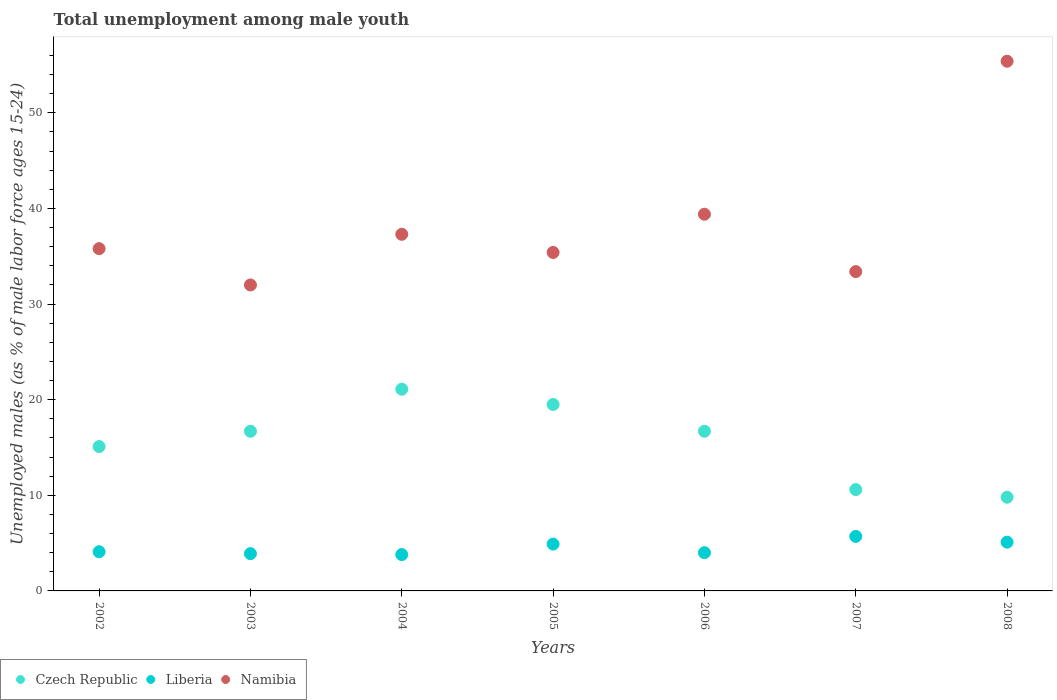How many different coloured dotlines are there?
Offer a very short reply. 3. What is the percentage of unemployed males in in Czech Republic in 2002?
Offer a terse response. 15.1. Across all years, what is the maximum percentage of unemployed males in in Liberia?
Offer a very short reply. 5.7. Across all years, what is the minimum percentage of unemployed males in in Liberia?
Make the answer very short. 3.8. In which year was the percentage of unemployed males in in Namibia maximum?
Provide a succinct answer. 2008. In which year was the percentage of unemployed males in in Namibia minimum?
Your response must be concise. 2003. What is the total percentage of unemployed males in in Liberia in the graph?
Offer a very short reply. 31.5. What is the difference between the percentage of unemployed males in in Czech Republic in 2002 and that in 2006?
Provide a short and direct response. -1.6. What is the difference between the percentage of unemployed males in in Namibia in 2004 and the percentage of unemployed males in in Czech Republic in 2007?
Your answer should be compact. 26.7. What is the average percentage of unemployed males in in Namibia per year?
Your response must be concise. 38.39. In the year 2005, what is the difference between the percentage of unemployed males in in Namibia and percentage of unemployed males in in Czech Republic?
Offer a very short reply. 15.9. What is the ratio of the percentage of unemployed males in in Namibia in 2005 to that in 2006?
Provide a succinct answer. 0.9. What is the difference between the highest and the second highest percentage of unemployed males in in Liberia?
Offer a very short reply. 0.6. What is the difference between the highest and the lowest percentage of unemployed males in in Namibia?
Offer a very short reply. 23.4. In how many years, is the percentage of unemployed males in in Liberia greater than the average percentage of unemployed males in in Liberia taken over all years?
Your answer should be very brief. 3. Is it the case that in every year, the sum of the percentage of unemployed males in in Namibia and percentage of unemployed males in in Czech Republic  is greater than the percentage of unemployed males in in Liberia?
Offer a terse response. Yes. How many years are there in the graph?
Provide a short and direct response. 7. Are the values on the major ticks of Y-axis written in scientific E-notation?
Offer a terse response. No. Does the graph contain any zero values?
Provide a short and direct response. No. Where does the legend appear in the graph?
Make the answer very short. Bottom left. What is the title of the graph?
Offer a very short reply. Total unemployment among male youth. Does "Turkmenistan" appear as one of the legend labels in the graph?
Offer a terse response. No. What is the label or title of the X-axis?
Offer a terse response. Years. What is the label or title of the Y-axis?
Your answer should be compact. Unemployed males (as % of male labor force ages 15-24). What is the Unemployed males (as % of male labor force ages 15-24) in Czech Republic in 2002?
Offer a very short reply. 15.1. What is the Unemployed males (as % of male labor force ages 15-24) in Liberia in 2002?
Provide a short and direct response. 4.1. What is the Unemployed males (as % of male labor force ages 15-24) in Namibia in 2002?
Offer a terse response. 35.8. What is the Unemployed males (as % of male labor force ages 15-24) of Czech Republic in 2003?
Keep it short and to the point. 16.7. What is the Unemployed males (as % of male labor force ages 15-24) in Liberia in 2003?
Ensure brevity in your answer.  3.9. What is the Unemployed males (as % of male labor force ages 15-24) in Namibia in 2003?
Provide a short and direct response. 32. What is the Unemployed males (as % of male labor force ages 15-24) in Czech Republic in 2004?
Ensure brevity in your answer.  21.1. What is the Unemployed males (as % of male labor force ages 15-24) of Liberia in 2004?
Provide a short and direct response. 3.8. What is the Unemployed males (as % of male labor force ages 15-24) of Namibia in 2004?
Provide a short and direct response. 37.3. What is the Unemployed males (as % of male labor force ages 15-24) in Czech Republic in 2005?
Your response must be concise. 19.5. What is the Unemployed males (as % of male labor force ages 15-24) in Liberia in 2005?
Your answer should be very brief. 4.9. What is the Unemployed males (as % of male labor force ages 15-24) of Namibia in 2005?
Provide a short and direct response. 35.4. What is the Unemployed males (as % of male labor force ages 15-24) of Czech Republic in 2006?
Offer a terse response. 16.7. What is the Unemployed males (as % of male labor force ages 15-24) in Namibia in 2006?
Give a very brief answer. 39.4. What is the Unemployed males (as % of male labor force ages 15-24) of Czech Republic in 2007?
Offer a very short reply. 10.6. What is the Unemployed males (as % of male labor force ages 15-24) of Liberia in 2007?
Provide a short and direct response. 5.7. What is the Unemployed males (as % of male labor force ages 15-24) of Namibia in 2007?
Ensure brevity in your answer.  33.4. What is the Unemployed males (as % of male labor force ages 15-24) of Czech Republic in 2008?
Your answer should be compact. 9.8. What is the Unemployed males (as % of male labor force ages 15-24) of Liberia in 2008?
Provide a short and direct response. 5.1. What is the Unemployed males (as % of male labor force ages 15-24) in Namibia in 2008?
Provide a short and direct response. 55.4. Across all years, what is the maximum Unemployed males (as % of male labor force ages 15-24) of Czech Republic?
Offer a terse response. 21.1. Across all years, what is the maximum Unemployed males (as % of male labor force ages 15-24) of Liberia?
Your answer should be very brief. 5.7. Across all years, what is the maximum Unemployed males (as % of male labor force ages 15-24) of Namibia?
Make the answer very short. 55.4. Across all years, what is the minimum Unemployed males (as % of male labor force ages 15-24) in Czech Republic?
Provide a short and direct response. 9.8. Across all years, what is the minimum Unemployed males (as % of male labor force ages 15-24) of Liberia?
Make the answer very short. 3.8. Across all years, what is the minimum Unemployed males (as % of male labor force ages 15-24) of Namibia?
Your answer should be very brief. 32. What is the total Unemployed males (as % of male labor force ages 15-24) in Czech Republic in the graph?
Keep it short and to the point. 109.5. What is the total Unemployed males (as % of male labor force ages 15-24) of Liberia in the graph?
Provide a succinct answer. 31.5. What is the total Unemployed males (as % of male labor force ages 15-24) of Namibia in the graph?
Offer a terse response. 268.7. What is the difference between the Unemployed males (as % of male labor force ages 15-24) of Liberia in 2002 and that in 2003?
Your answer should be compact. 0.2. What is the difference between the Unemployed males (as % of male labor force ages 15-24) of Namibia in 2002 and that in 2003?
Keep it short and to the point. 3.8. What is the difference between the Unemployed males (as % of male labor force ages 15-24) in Namibia in 2002 and that in 2004?
Provide a short and direct response. -1.5. What is the difference between the Unemployed males (as % of male labor force ages 15-24) in Liberia in 2002 and that in 2005?
Offer a terse response. -0.8. What is the difference between the Unemployed males (as % of male labor force ages 15-24) of Czech Republic in 2002 and that in 2006?
Your answer should be very brief. -1.6. What is the difference between the Unemployed males (as % of male labor force ages 15-24) of Liberia in 2002 and that in 2006?
Offer a very short reply. 0.1. What is the difference between the Unemployed males (as % of male labor force ages 15-24) of Namibia in 2002 and that in 2006?
Your answer should be compact. -3.6. What is the difference between the Unemployed males (as % of male labor force ages 15-24) in Liberia in 2002 and that in 2007?
Offer a terse response. -1.6. What is the difference between the Unemployed males (as % of male labor force ages 15-24) in Namibia in 2002 and that in 2008?
Your response must be concise. -19.6. What is the difference between the Unemployed males (as % of male labor force ages 15-24) in Czech Republic in 2003 and that in 2005?
Give a very brief answer. -2.8. What is the difference between the Unemployed males (as % of male labor force ages 15-24) in Czech Republic in 2003 and that in 2006?
Make the answer very short. 0. What is the difference between the Unemployed males (as % of male labor force ages 15-24) of Liberia in 2003 and that in 2006?
Offer a terse response. -0.1. What is the difference between the Unemployed males (as % of male labor force ages 15-24) in Liberia in 2003 and that in 2007?
Give a very brief answer. -1.8. What is the difference between the Unemployed males (as % of male labor force ages 15-24) of Namibia in 2003 and that in 2007?
Your answer should be very brief. -1.4. What is the difference between the Unemployed males (as % of male labor force ages 15-24) of Namibia in 2003 and that in 2008?
Make the answer very short. -23.4. What is the difference between the Unemployed males (as % of male labor force ages 15-24) of Czech Republic in 2004 and that in 2005?
Your answer should be compact. 1.6. What is the difference between the Unemployed males (as % of male labor force ages 15-24) of Liberia in 2004 and that in 2005?
Your answer should be compact. -1.1. What is the difference between the Unemployed males (as % of male labor force ages 15-24) in Namibia in 2004 and that in 2005?
Keep it short and to the point. 1.9. What is the difference between the Unemployed males (as % of male labor force ages 15-24) of Czech Republic in 2004 and that in 2006?
Provide a succinct answer. 4.4. What is the difference between the Unemployed males (as % of male labor force ages 15-24) of Liberia in 2004 and that in 2006?
Offer a terse response. -0.2. What is the difference between the Unemployed males (as % of male labor force ages 15-24) of Namibia in 2004 and that in 2006?
Your response must be concise. -2.1. What is the difference between the Unemployed males (as % of male labor force ages 15-24) in Liberia in 2004 and that in 2007?
Keep it short and to the point. -1.9. What is the difference between the Unemployed males (as % of male labor force ages 15-24) in Liberia in 2004 and that in 2008?
Keep it short and to the point. -1.3. What is the difference between the Unemployed males (as % of male labor force ages 15-24) of Namibia in 2004 and that in 2008?
Ensure brevity in your answer.  -18.1. What is the difference between the Unemployed males (as % of male labor force ages 15-24) in Liberia in 2005 and that in 2006?
Make the answer very short. 0.9. What is the difference between the Unemployed males (as % of male labor force ages 15-24) of Namibia in 2005 and that in 2006?
Make the answer very short. -4. What is the difference between the Unemployed males (as % of male labor force ages 15-24) of Czech Republic in 2005 and that in 2007?
Keep it short and to the point. 8.9. What is the difference between the Unemployed males (as % of male labor force ages 15-24) in Czech Republic in 2005 and that in 2008?
Your answer should be very brief. 9.7. What is the difference between the Unemployed males (as % of male labor force ages 15-24) in Namibia in 2005 and that in 2008?
Keep it short and to the point. -20. What is the difference between the Unemployed males (as % of male labor force ages 15-24) of Czech Republic in 2006 and that in 2008?
Make the answer very short. 6.9. What is the difference between the Unemployed males (as % of male labor force ages 15-24) in Czech Republic in 2007 and that in 2008?
Your answer should be compact. 0.8. What is the difference between the Unemployed males (as % of male labor force ages 15-24) of Liberia in 2007 and that in 2008?
Provide a succinct answer. 0.6. What is the difference between the Unemployed males (as % of male labor force ages 15-24) of Namibia in 2007 and that in 2008?
Your answer should be very brief. -22. What is the difference between the Unemployed males (as % of male labor force ages 15-24) of Czech Republic in 2002 and the Unemployed males (as % of male labor force ages 15-24) of Liberia in 2003?
Your response must be concise. 11.2. What is the difference between the Unemployed males (as % of male labor force ages 15-24) of Czech Republic in 2002 and the Unemployed males (as % of male labor force ages 15-24) of Namibia in 2003?
Your answer should be very brief. -16.9. What is the difference between the Unemployed males (as % of male labor force ages 15-24) in Liberia in 2002 and the Unemployed males (as % of male labor force ages 15-24) in Namibia in 2003?
Make the answer very short. -27.9. What is the difference between the Unemployed males (as % of male labor force ages 15-24) of Czech Republic in 2002 and the Unemployed males (as % of male labor force ages 15-24) of Liberia in 2004?
Ensure brevity in your answer.  11.3. What is the difference between the Unemployed males (as % of male labor force ages 15-24) of Czech Republic in 2002 and the Unemployed males (as % of male labor force ages 15-24) of Namibia in 2004?
Keep it short and to the point. -22.2. What is the difference between the Unemployed males (as % of male labor force ages 15-24) of Liberia in 2002 and the Unemployed males (as % of male labor force ages 15-24) of Namibia in 2004?
Keep it short and to the point. -33.2. What is the difference between the Unemployed males (as % of male labor force ages 15-24) in Czech Republic in 2002 and the Unemployed males (as % of male labor force ages 15-24) in Namibia in 2005?
Your answer should be compact. -20.3. What is the difference between the Unemployed males (as % of male labor force ages 15-24) in Liberia in 2002 and the Unemployed males (as % of male labor force ages 15-24) in Namibia in 2005?
Offer a terse response. -31.3. What is the difference between the Unemployed males (as % of male labor force ages 15-24) of Czech Republic in 2002 and the Unemployed males (as % of male labor force ages 15-24) of Namibia in 2006?
Offer a terse response. -24.3. What is the difference between the Unemployed males (as % of male labor force ages 15-24) of Liberia in 2002 and the Unemployed males (as % of male labor force ages 15-24) of Namibia in 2006?
Make the answer very short. -35.3. What is the difference between the Unemployed males (as % of male labor force ages 15-24) in Czech Republic in 2002 and the Unemployed males (as % of male labor force ages 15-24) in Liberia in 2007?
Keep it short and to the point. 9.4. What is the difference between the Unemployed males (as % of male labor force ages 15-24) of Czech Republic in 2002 and the Unemployed males (as % of male labor force ages 15-24) of Namibia in 2007?
Provide a succinct answer. -18.3. What is the difference between the Unemployed males (as % of male labor force ages 15-24) in Liberia in 2002 and the Unemployed males (as % of male labor force ages 15-24) in Namibia in 2007?
Provide a short and direct response. -29.3. What is the difference between the Unemployed males (as % of male labor force ages 15-24) of Czech Republic in 2002 and the Unemployed males (as % of male labor force ages 15-24) of Namibia in 2008?
Make the answer very short. -40.3. What is the difference between the Unemployed males (as % of male labor force ages 15-24) in Liberia in 2002 and the Unemployed males (as % of male labor force ages 15-24) in Namibia in 2008?
Your answer should be compact. -51.3. What is the difference between the Unemployed males (as % of male labor force ages 15-24) in Czech Republic in 2003 and the Unemployed males (as % of male labor force ages 15-24) in Namibia in 2004?
Your answer should be very brief. -20.6. What is the difference between the Unemployed males (as % of male labor force ages 15-24) of Liberia in 2003 and the Unemployed males (as % of male labor force ages 15-24) of Namibia in 2004?
Keep it short and to the point. -33.4. What is the difference between the Unemployed males (as % of male labor force ages 15-24) in Czech Republic in 2003 and the Unemployed males (as % of male labor force ages 15-24) in Liberia in 2005?
Your answer should be compact. 11.8. What is the difference between the Unemployed males (as % of male labor force ages 15-24) of Czech Republic in 2003 and the Unemployed males (as % of male labor force ages 15-24) of Namibia in 2005?
Keep it short and to the point. -18.7. What is the difference between the Unemployed males (as % of male labor force ages 15-24) of Liberia in 2003 and the Unemployed males (as % of male labor force ages 15-24) of Namibia in 2005?
Provide a succinct answer. -31.5. What is the difference between the Unemployed males (as % of male labor force ages 15-24) in Czech Republic in 2003 and the Unemployed males (as % of male labor force ages 15-24) in Namibia in 2006?
Give a very brief answer. -22.7. What is the difference between the Unemployed males (as % of male labor force ages 15-24) of Liberia in 2003 and the Unemployed males (as % of male labor force ages 15-24) of Namibia in 2006?
Give a very brief answer. -35.5. What is the difference between the Unemployed males (as % of male labor force ages 15-24) in Czech Republic in 2003 and the Unemployed males (as % of male labor force ages 15-24) in Namibia in 2007?
Offer a terse response. -16.7. What is the difference between the Unemployed males (as % of male labor force ages 15-24) of Liberia in 2003 and the Unemployed males (as % of male labor force ages 15-24) of Namibia in 2007?
Provide a short and direct response. -29.5. What is the difference between the Unemployed males (as % of male labor force ages 15-24) in Czech Republic in 2003 and the Unemployed males (as % of male labor force ages 15-24) in Liberia in 2008?
Make the answer very short. 11.6. What is the difference between the Unemployed males (as % of male labor force ages 15-24) of Czech Republic in 2003 and the Unemployed males (as % of male labor force ages 15-24) of Namibia in 2008?
Your response must be concise. -38.7. What is the difference between the Unemployed males (as % of male labor force ages 15-24) of Liberia in 2003 and the Unemployed males (as % of male labor force ages 15-24) of Namibia in 2008?
Give a very brief answer. -51.5. What is the difference between the Unemployed males (as % of male labor force ages 15-24) of Czech Republic in 2004 and the Unemployed males (as % of male labor force ages 15-24) of Namibia in 2005?
Your answer should be very brief. -14.3. What is the difference between the Unemployed males (as % of male labor force ages 15-24) in Liberia in 2004 and the Unemployed males (as % of male labor force ages 15-24) in Namibia in 2005?
Your response must be concise. -31.6. What is the difference between the Unemployed males (as % of male labor force ages 15-24) in Czech Republic in 2004 and the Unemployed males (as % of male labor force ages 15-24) in Liberia in 2006?
Your answer should be very brief. 17.1. What is the difference between the Unemployed males (as % of male labor force ages 15-24) in Czech Republic in 2004 and the Unemployed males (as % of male labor force ages 15-24) in Namibia in 2006?
Keep it short and to the point. -18.3. What is the difference between the Unemployed males (as % of male labor force ages 15-24) of Liberia in 2004 and the Unemployed males (as % of male labor force ages 15-24) of Namibia in 2006?
Provide a short and direct response. -35.6. What is the difference between the Unemployed males (as % of male labor force ages 15-24) of Czech Republic in 2004 and the Unemployed males (as % of male labor force ages 15-24) of Liberia in 2007?
Your response must be concise. 15.4. What is the difference between the Unemployed males (as % of male labor force ages 15-24) of Liberia in 2004 and the Unemployed males (as % of male labor force ages 15-24) of Namibia in 2007?
Your answer should be compact. -29.6. What is the difference between the Unemployed males (as % of male labor force ages 15-24) of Czech Republic in 2004 and the Unemployed males (as % of male labor force ages 15-24) of Namibia in 2008?
Provide a succinct answer. -34.3. What is the difference between the Unemployed males (as % of male labor force ages 15-24) of Liberia in 2004 and the Unemployed males (as % of male labor force ages 15-24) of Namibia in 2008?
Keep it short and to the point. -51.6. What is the difference between the Unemployed males (as % of male labor force ages 15-24) of Czech Republic in 2005 and the Unemployed males (as % of male labor force ages 15-24) of Liberia in 2006?
Give a very brief answer. 15.5. What is the difference between the Unemployed males (as % of male labor force ages 15-24) in Czech Republic in 2005 and the Unemployed males (as % of male labor force ages 15-24) in Namibia in 2006?
Your answer should be very brief. -19.9. What is the difference between the Unemployed males (as % of male labor force ages 15-24) of Liberia in 2005 and the Unemployed males (as % of male labor force ages 15-24) of Namibia in 2006?
Ensure brevity in your answer.  -34.5. What is the difference between the Unemployed males (as % of male labor force ages 15-24) in Liberia in 2005 and the Unemployed males (as % of male labor force ages 15-24) in Namibia in 2007?
Your response must be concise. -28.5. What is the difference between the Unemployed males (as % of male labor force ages 15-24) of Czech Republic in 2005 and the Unemployed males (as % of male labor force ages 15-24) of Liberia in 2008?
Make the answer very short. 14.4. What is the difference between the Unemployed males (as % of male labor force ages 15-24) of Czech Republic in 2005 and the Unemployed males (as % of male labor force ages 15-24) of Namibia in 2008?
Offer a terse response. -35.9. What is the difference between the Unemployed males (as % of male labor force ages 15-24) of Liberia in 2005 and the Unemployed males (as % of male labor force ages 15-24) of Namibia in 2008?
Your response must be concise. -50.5. What is the difference between the Unemployed males (as % of male labor force ages 15-24) of Czech Republic in 2006 and the Unemployed males (as % of male labor force ages 15-24) of Liberia in 2007?
Provide a succinct answer. 11. What is the difference between the Unemployed males (as % of male labor force ages 15-24) in Czech Republic in 2006 and the Unemployed males (as % of male labor force ages 15-24) in Namibia in 2007?
Ensure brevity in your answer.  -16.7. What is the difference between the Unemployed males (as % of male labor force ages 15-24) of Liberia in 2006 and the Unemployed males (as % of male labor force ages 15-24) of Namibia in 2007?
Your answer should be compact. -29.4. What is the difference between the Unemployed males (as % of male labor force ages 15-24) of Czech Republic in 2006 and the Unemployed males (as % of male labor force ages 15-24) of Liberia in 2008?
Provide a succinct answer. 11.6. What is the difference between the Unemployed males (as % of male labor force ages 15-24) of Czech Republic in 2006 and the Unemployed males (as % of male labor force ages 15-24) of Namibia in 2008?
Make the answer very short. -38.7. What is the difference between the Unemployed males (as % of male labor force ages 15-24) in Liberia in 2006 and the Unemployed males (as % of male labor force ages 15-24) in Namibia in 2008?
Your response must be concise. -51.4. What is the difference between the Unemployed males (as % of male labor force ages 15-24) of Czech Republic in 2007 and the Unemployed males (as % of male labor force ages 15-24) of Liberia in 2008?
Ensure brevity in your answer.  5.5. What is the difference between the Unemployed males (as % of male labor force ages 15-24) of Czech Republic in 2007 and the Unemployed males (as % of male labor force ages 15-24) of Namibia in 2008?
Offer a very short reply. -44.8. What is the difference between the Unemployed males (as % of male labor force ages 15-24) of Liberia in 2007 and the Unemployed males (as % of male labor force ages 15-24) of Namibia in 2008?
Offer a very short reply. -49.7. What is the average Unemployed males (as % of male labor force ages 15-24) in Czech Republic per year?
Keep it short and to the point. 15.64. What is the average Unemployed males (as % of male labor force ages 15-24) of Namibia per year?
Provide a short and direct response. 38.39. In the year 2002, what is the difference between the Unemployed males (as % of male labor force ages 15-24) of Czech Republic and Unemployed males (as % of male labor force ages 15-24) of Liberia?
Your response must be concise. 11. In the year 2002, what is the difference between the Unemployed males (as % of male labor force ages 15-24) in Czech Republic and Unemployed males (as % of male labor force ages 15-24) in Namibia?
Offer a terse response. -20.7. In the year 2002, what is the difference between the Unemployed males (as % of male labor force ages 15-24) in Liberia and Unemployed males (as % of male labor force ages 15-24) in Namibia?
Your answer should be compact. -31.7. In the year 2003, what is the difference between the Unemployed males (as % of male labor force ages 15-24) in Czech Republic and Unemployed males (as % of male labor force ages 15-24) in Namibia?
Your response must be concise. -15.3. In the year 2003, what is the difference between the Unemployed males (as % of male labor force ages 15-24) in Liberia and Unemployed males (as % of male labor force ages 15-24) in Namibia?
Provide a short and direct response. -28.1. In the year 2004, what is the difference between the Unemployed males (as % of male labor force ages 15-24) in Czech Republic and Unemployed males (as % of male labor force ages 15-24) in Namibia?
Give a very brief answer. -16.2. In the year 2004, what is the difference between the Unemployed males (as % of male labor force ages 15-24) of Liberia and Unemployed males (as % of male labor force ages 15-24) of Namibia?
Keep it short and to the point. -33.5. In the year 2005, what is the difference between the Unemployed males (as % of male labor force ages 15-24) of Czech Republic and Unemployed males (as % of male labor force ages 15-24) of Liberia?
Offer a very short reply. 14.6. In the year 2005, what is the difference between the Unemployed males (as % of male labor force ages 15-24) in Czech Republic and Unemployed males (as % of male labor force ages 15-24) in Namibia?
Make the answer very short. -15.9. In the year 2005, what is the difference between the Unemployed males (as % of male labor force ages 15-24) of Liberia and Unemployed males (as % of male labor force ages 15-24) of Namibia?
Provide a succinct answer. -30.5. In the year 2006, what is the difference between the Unemployed males (as % of male labor force ages 15-24) in Czech Republic and Unemployed males (as % of male labor force ages 15-24) in Liberia?
Provide a short and direct response. 12.7. In the year 2006, what is the difference between the Unemployed males (as % of male labor force ages 15-24) of Czech Republic and Unemployed males (as % of male labor force ages 15-24) of Namibia?
Ensure brevity in your answer.  -22.7. In the year 2006, what is the difference between the Unemployed males (as % of male labor force ages 15-24) in Liberia and Unemployed males (as % of male labor force ages 15-24) in Namibia?
Give a very brief answer. -35.4. In the year 2007, what is the difference between the Unemployed males (as % of male labor force ages 15-24) in Czech Republic and Unemployed males (as % of male labor force ages 15-24) in Liberia?
Your answer should be very brief. 4.9. In the year 2007, what is the difference between the Unemployed males (as % of male labor force ages 15-24) of Czech Republic and Unemployed males (as % of male labor force ages 15-24) of Namibia?
Give a very brief answer. -22.8. In the year 2007, what is the difference between the Unemployed males (as % of male labor force ages 15-24) of Liberia and Unemployed males (as % of male labor force ages 15-24) of Namibia?
Offer a terse response. -27.7. In the year 2008, what is the difference between the Unemployed males (as % of male labor force ages 15-24) in Czech Republic and Unemployed males (as % of male labor force ages 15-24) in Namibia?
Ensure brevity in your answer.  -45.6. In the year 2008, what is the difference between the Unemployed males (as % of male labor force ages 15-24) in Liberia and Unemployed males (as % of male labor force ages 15-24) in Namibia?
Your answer should be compact. -50.3. What is the ratio of the Unemployed males (as % of male labor force ages 15-24) of Czech Republic in 2002 to that in 2003?
Your answer should be compact. 0.9. What is the ratio of the Unemployed males (as % of male labor force ages 15-24) in Liberia in 2002 to that in 2003?
Your answer should be compact. 1.05. What is the ratio of the Unemployed males (as % of male labor force ages 15-24) of Namibia in 2002 to that in 2003?
Give a very brief answer. 1.12. What is the ratio of the Unemployed males (as % of male labor force ages 15-24) in Czech Republic in 2002 to that in 2004?
Your response must be concise. 0.72. What is the ratio of the Unemployed males (as % of male labor force ages 15-24) of Liberia in 2002 to that in 2004?
Your answer should be very brief. 1.08. What is the ratio of the Unemployed males (as % of male labor force ages 15-24) of Namibia in 2002 to that in 2004?
Provide a succinct answer. 0.96. What is the ratio of the Unemployed males (as % of male labor force ages 15-24) of Czech Republic in 2002 to that in 2005?
Make the answer very short. 0.77. What is the ratio of the Unemployed males (as % of male labor force ages 15-24) in Liberia in 2002 to that in 2005?
Offer a very short reply. 0.84. What is the ratio of the Unemployed males (as % of male labor force ages 15-24) of Namibia in 2002 to that in 2005?
Make the answer very short. 1.01. What is the ratio of the Unemployed males (as % of male labor force ages 15-24) in Czech Republic in 2002 to that in 2006?
Provide a succinct answer. 0.9. What is the ratio of the Unemployed males (as % of male labor force ages 15-24) in Namibia in 2002 to that in 2006?
Offer a very short reply. 0.91. What is the ratio of the Unemployed males (as % of male labor force ages 15-24) of Czech Republic in 2002 to that in 2007?
Make the answer very short. 1.42. What is the ratio of the Unemployed males (as % of male labor force ages 15-24) in Liberia in 2002 to that in 2007?
Offer a terse response. 0.72. What is the ratio of the Unemployed males (as % of male labor force ages 15-24) of Namibia in 2002 to that in 2007?
Offer a very short reply. 1.07. What is the ratio of the Unemployed males (as % of male labor force ages 15-24) of Czech Republic in 2002 to that in 2008?
Your answer should be very brief. 1.54. What is the ratio of the Unemployed males (as % of male labor force ages 15-24) of Liberia in 2002 to that in 2008?
Give a very brief answer. 0.8. What is the ratio of the Unemployed males (as % of male labor force ages 15-24) of Namibia in 2002 to that in 2008?
Offer a terse response. 0.65. What is the ratio of the Unemployed males (as % of male labor force ages 15-24) in Czech Republic in 2003 to that in 2004?
Give a very brief answer. 0.79. What is the ratio of the Unemployed males (as % of male labor force ages 15-24) of Liberia in 2003 to that in 2004?
Offer a terse response. 1.03. What is the ratio of the Unemployed males (as % of male labor force ages 15-24) of Namibia in 2003 to that in 2004?
Your answer should be compact. 0.86. What is the ratio of the Unemployed males (as % of male labor force ages 15-24) in Czech Republic in 2003 to that in 2005?
Your response must be concise. 0.86. What is the ratio of the Unemployed males (as % of male labor force ages 15-24) of Liberia in 2003 to that in 2005?
Provide a short and direct response. 0.8. What is the ratio of the Unemployed males (as % of male labor force ages 15-24) of Namibia in 2003 to that in 2005?
Provide a short and direct response. 0.9. What is the ratio of the Unemployed males (as % of male labor force ages 15-24) of Czech Republic in 2003 to that in 2006?
Provide a succinct answer. 1. What is the ratio of the Unemployed males (as % of male labor force ages 15-24) of Liberia in 2003 to that in 2006?
Your answer should be compact. 0.97. What is the ratio of the Unemployed males (as % of male labor force ages 15-24) in Namibia in 2003 to that in 2006?
Give a very brief answer. 0.81. What is the ratio of the Unemployed males (as % of male labor force ages 15-24) of Czech Republic in 2003 to that in 2007?
Provide a succinct answer. 1.58. What is the ratio of the Unemployed males (as % of male labor force ages 15-24) of Liberia in 2003 to that in 2007?
Your answer should be compact. 0.68. What is the ratio of the Unemployed males (as % of male labor force ages 15-24) of Namibia in 2003 to that in 2007?
Keep it short and to the point. 0.96. What is the ratio of the Unemployed males (as % of male labor force ages 15-24) of Czech Republic in 2003 to that in 2008?
Make the answer very short. 1.7. What is the ratio of the Unemployed males (as % of male labor force ages 15-24) of Liberia in 2003 to that in 2008?
Your response must be concise. 0.76. What is the ratio of the Unemployed males (as % of male labor force ages 15-24) of Namibia in 2003 to that in 2008?
Your answer should be compact. 0.58. What is the ratio of the Unemployed males (as % of male labor force ages 15-24) in Czech Republic in 2004 to that in 2005?
Ensure brevity in your answer.  1.08. What is the ratio of the Unemployed males (as % of male labor force ages 15-24) in Liberia in 2004 to that in 2005?
Offer a terse response. 0.78. What is the ratio of the Unemployed males (as % of male labor force ages 15-24) of Namibia in 2004 to that in 2005?
Ensure brevity in your answer.  1.05. What is the ratio of the Unemployed males (as % of male labor force ages 15-24) of Czech Republic in 2004 to that in 2006?
Your answer should be compact. 1.26. What is the ratio of the Unemployed males (as % of male labor force ages 15-24) of Namibia in 2004 to that in 2006?
Ensure brevity in your answer.  0.95. What is the ratio of the Unemployed males (as % of male labor force ages 15-24) in Czech Republic in 2004 to that in 2007?
Offer a terse response. 1.99. What is the ratio of the Unemployed males (as % of male labor force ages 15-24) in Namibia in 2004 to that in 2007?
Your response must be concise. 1.12. What is the ratio of the Unemployed males (as % of male labor force ages 15-24) of Czech Republic in 2004 to that in 2008?
Make the answer very short. 2.15. What is the ratio of the Unemployed males (as % of male labor force ages 15-24) in Liberia in 2004 to that in 2008?
Offer a very short reply. 0.75. What is the ratio of the Unemployed males (as % of male labor force ages 15-24) in Namibia in 2004 to that in 2008?
Give a very brief answer. 0.67. What is the ratio of the Unemployed males (as % of male labor force ages 15-24) of Czech Republic in 2005 to that in 2006?
Offer a terse response. 1.17. What is the ratio of the Unemployed males (as % of male labor force ages 15-24) in Liberia in 2005 to that in 2006?
Give a very brief answer. 1.23. What is the ratio of the Unemployed males (as % of male labor force ages 15-24) of Namibia in 2005 to that in 2006?
Give a very brief answer. 0.9. What is the ratio of the Unemployed males (as % of male labor force ages 15-24) of Czech Republic in 2005 to that in 2007?
Offer a terse response. 1.84. What is the ratio of the Unemployed males (as % of male labor force ages 15-24) in Liberia in 2005 to that in 2007?
Your answer should be compact. 0.86. What is the ratio of the Unemployed males (as % of male labor force ages 15-24) of Namibia in 2005 to that in 2007?
Provide a short and direct response. 1.06. What is the ratio of the Unemployed males (as % of male labor force ages 15-24) in Czech Republic in 2005 to that in 2008?
Keep it short and to the point. 1.99. What is the ratio of the Unemployed males (as % of male labor force ages 15-24) of Liberia in 2005 to that in 2008?
Offer a very short reply. 0.96. What is the ratio of the Unemployed males (as % of male labor force ages 15-24) of Namibia in 2005 to that in 2008?
Make the answer very short. 0.64. What is the ratio of the Unemployed males (as % of male labor force ages 15-24) of Czech Republic in 2006 to that in 2007?
Offer a very short reply. 1.58. What is the ratio of the Unemployed males (as % of male labor force ages 15-24) of Liberia in 2006 to that in 2007?
Your answer should be very brief. 0.7. What is the ratio of the Unemployed males (as % of male labor force ages 15-24) of Namibia in 2006 to that in 2007?
Make the answer very short. 1.18. What is the ratio of the Unemployed males (as % of male labor force ages 15-24) in Czech Republic in 2006 to that in 2008?
Give a very brief answer. 1.7. What is the ratio of the Unemployed males (as % of male labor force ages 15-24) in Liberia in 2006 to that in 2008?
Ensure brevity in your answer.  0.78. What is the ratio of the Unemployed males (as % of male labor force ages 15-24) of Namibia in 2006 to that in 2008?
Keep it short and to the point. 0.71. What is the ratio of the Unemployed males (as % of male labor force ages 15-24) in Czech Republic in 2007 to that in 2008?
Provide a short and direct response. 1.08. What is the ratio of the Unemployed males (as % of male labor force ages 15-24) in Liberia in 2007 to that in 2008?
Your answer should be compact. 1.12. What is the ratio of the Unemployed males (as % of male labor force ages 15-24) of Namibia in 2007 to that in 2008?
Provide a succinct answer. 0.6. What is the difference between the highest and the second highest Unemployed males (as % of male labor force ages 15-24) of Czech Republic?
Give a very brief answer. 1.6. What is the difference between the highest and the second highest Unemployed males (as % of male labor force ages 15-24) of Liberia?
Ensure brevity in your answer.  0.6. What is the difference between the highest and the second highest Unemployed males (as % of male labor force ages 15-24) in Namibia?
Offer a very short reply. 16. What is the difference between the highest and the lowest Unemployed males (as % of male labor force ages 15-24) of Namibia?
Keep it short and to the point. 23.4. 